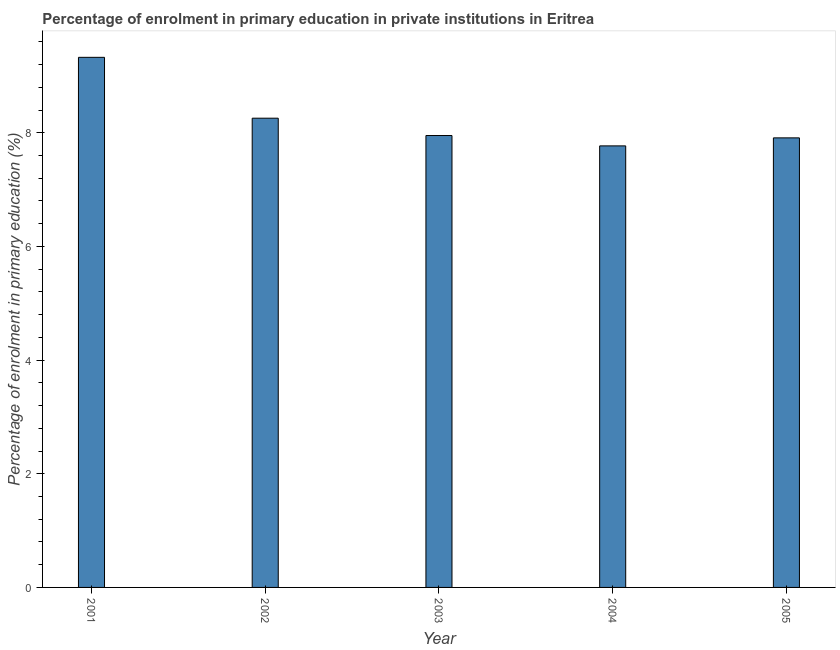Does the graph contain any zero values?
Your answer should be compact. No. What is the title of the graph?
Provide a short and direct response. Percentage of enrolment in primary education in private institutions in Eritrea. What is the label or title of the X-axis?
Your answer should be very brief. Year. What is the label or title of the Y-axis?
Provide a short and direct response. Percentage of enrolment in primary education (%). What is the enrolment percentage in primary education in 2003?
Your answer should be compact. 7.95. Across all years, what is the maximum enrolment percentage in primary education?
Make the answer very short. 9.33. Across all years, what is the minimum enrolment percentage in primary education?
Offer a very short reply. 7.77. What is the sum of the enrolment percentage in primary education?
Ensure brevity in your answer.  41.21. What is the difference between the enrolment percentage in primary education in 2001 and 2004?
Your answer should be compact. 1.56. What is the average enrolment percentage in primary education per year?
Your response must be concise. 8.24. What is the median enrolment percentage in primary education?
Your response must be concise. 7.95. Do a majority of the years between 2001 and 2005 (inclusive) have enrolment percentage in primary education greater than 4 %?
Your answer should be compact. Yes. What is the ratio of the enrolment percentage in primary education in 2003 to that in 2004?
Your response must be concise. 1.02. What is the difference between the highest and the second highest enrolment percentage in primary education?
Offer a very short reply. 1.07. What is the difference between the highest and the lowest enrolment percentage in primary education?
Make the answer very short. 1.56. How many bars are there?
Provide a short and direct response. 5. How many years are there in the graph?
Offer a terse response. 5. What is the difference between two consecutive major ticks on the Y-axis?
Keep it short and to the point. 2. What is the Percentage of enrolment in primary education (%) of 2001?
Keep it short and to the point. 9.33. What is the Percentage of enrolment in primary education (%) of 2002?
Your response must be concise. 8.26. What is the Percentage of enrolment in primary education (%) in 2003?
Your response must be concise. 7.95. What is the Percentage of enrolment in primary education (%) in 2004?
Make the answer very short. 7.77. What is the Percentage of enrolment in primary education (%) in 2005?
Give a very brief answer. 7.91. What is the difference between the Percentage of enrolment in primary education (%) in 2001 and 2002?
Make the answer very short. 1.07. What is the difference between the Percentage of enrolment in primary education (%) in 2001 and 2003?
Provide a short and direct response. 1.38. What is the difference between the Percentage of enrolment in primary education (%) in 2001 and 2004?
Offer a terse response. 1.56. What is the difference between the Percentage of enrolment in primary education (%) in 2001 and 2005?
Provide a short and direct response. 1.42. What is the difference between the Percentage of enrolment in primary education (%) in 2002 and 2003?
Provide a succinct answer. 0.3. What is the difference between the Percentage of enrolment in primary education (%) in 2002 and 2004?
Provide a short and direct response. 0.49. What is the difference between the Percentage of enrolment in primary education (%) in 2002 and 2005?
Your answer should be very brief. 0.35. What is the difference between the Percentage of enrolment in primary education (%) in 2003 and 2004?
Your answer should be compact. 0.18. What is the difference between the Percentage of enrolment in primary education (%) in 2003 and 2005?
Your answer should be very brief. 0.04. What is the difference between the Percentage of enrolment in primary education (%) in 2004 and 2005?
Offer a very short reply. -0.14. What is the ratio of the Percentage of enrolment in primary education (%) in 2001 to that in 2002?
Your answer should be very brief. 1.13. What is the ratio of the Percentage of enrolment in primary education (%) in 2001 to that in 2003?
Provide a short and direct response. 1.17. What is the ratio of the Percentage of enrolment in primary education (%) in 2001 to that in 2004?
Offer a terse response. 1.2. What is the ratio of the Percentage of enrolment in primary education (%) in 2001 to that in 2005?
Make the answer very short. 1.18. What is the ratio of the Percentage of enrolment in primary education (%) in 2002 to that in 2003?
Provide a short and direct response. 1.04. What is the ratio of the Percentage of enrolment in primary education (%) in 2002 to that in 2004?
Keep it short and to the point. 1.06. What is the ratio of the Percentage of enrolment in primary education (%) in 2002 to that in 2005?
Your answer should be very brief. 1.04. What is the ratio of the Percentage of enrolment in primary education (%) in 2003 to that in 2005?
Give a very brief answer. 1. 